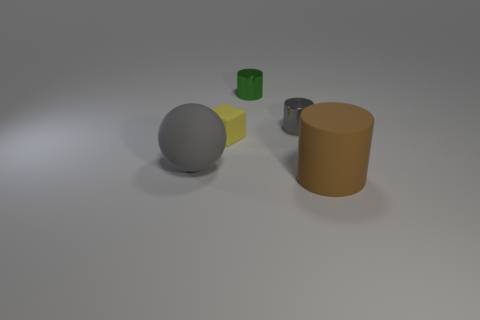Subtract all gray cylinders. How many cylinders are left? 2 Subtract all big cylinders. How many cylinders are left? 2 Subtract all cubes. How many objects are left? 4 Subtract all brown cylinders. Subtract all purple balls. How many cylinders are left? 2 Subtract all green balls. How many green cylinders are left? 1 Add 3 large brown matte cylinders. How many objects exist? 8 Subtract all small cylinders. Subtract all matte balls. How many objects are left? 2 Add 4 tiny metallic objects. How many tiny metallic objects are left? 6 Add 3 tiny gray metal balls. How many tiny gray metal balls exist? 3 Subtract 0 brown blocks. How many objects are left? 5 